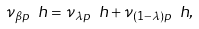Convert formula to latex. <formula><loc_0><loc_0><loc_500><loc_500>\nu _ { \beta p } \ h = \nu _ { \lambda p } \ h + \nu _ { ( 1 - \lambda ) p } \ h ,</formula> 